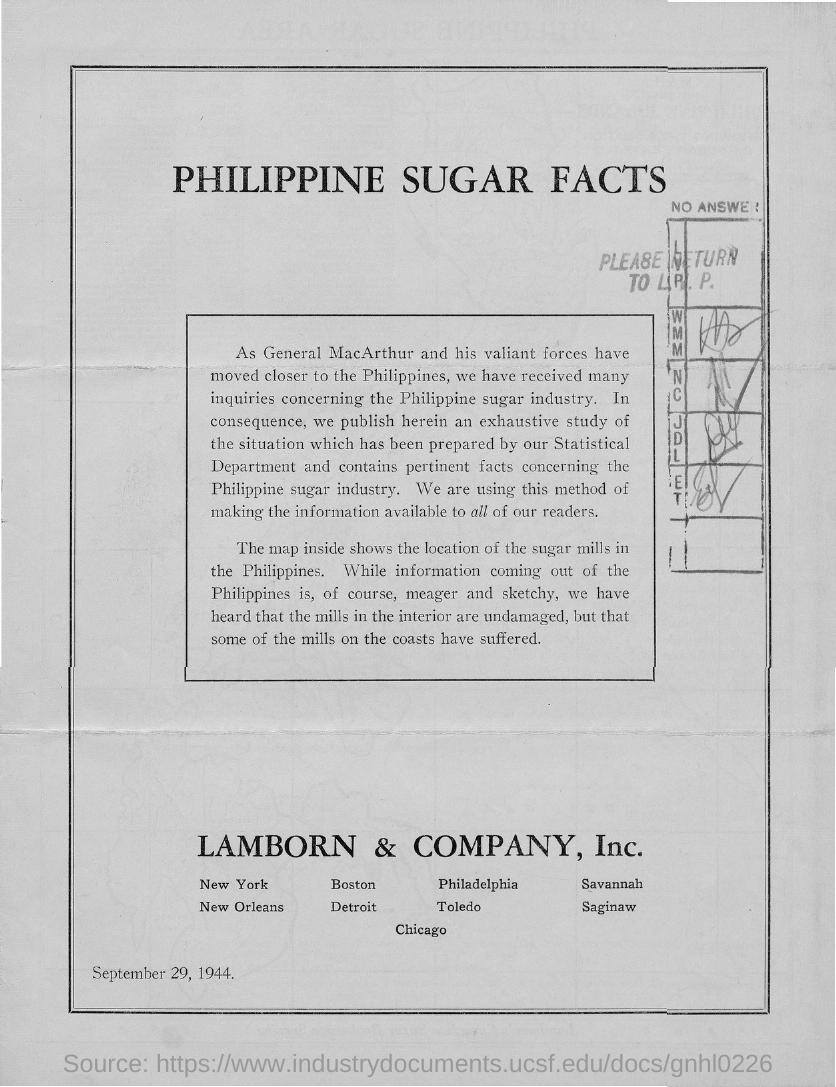What is the title of this document?
Provide a succinct answer. PHILIPPINE SUGAR FACTS. What is the date mentioned in this document?
Your response must be concise. September 29, 1944. Which company is mentioned in this document?
Your answer should be compact. Lamborn & Company, Inc. 